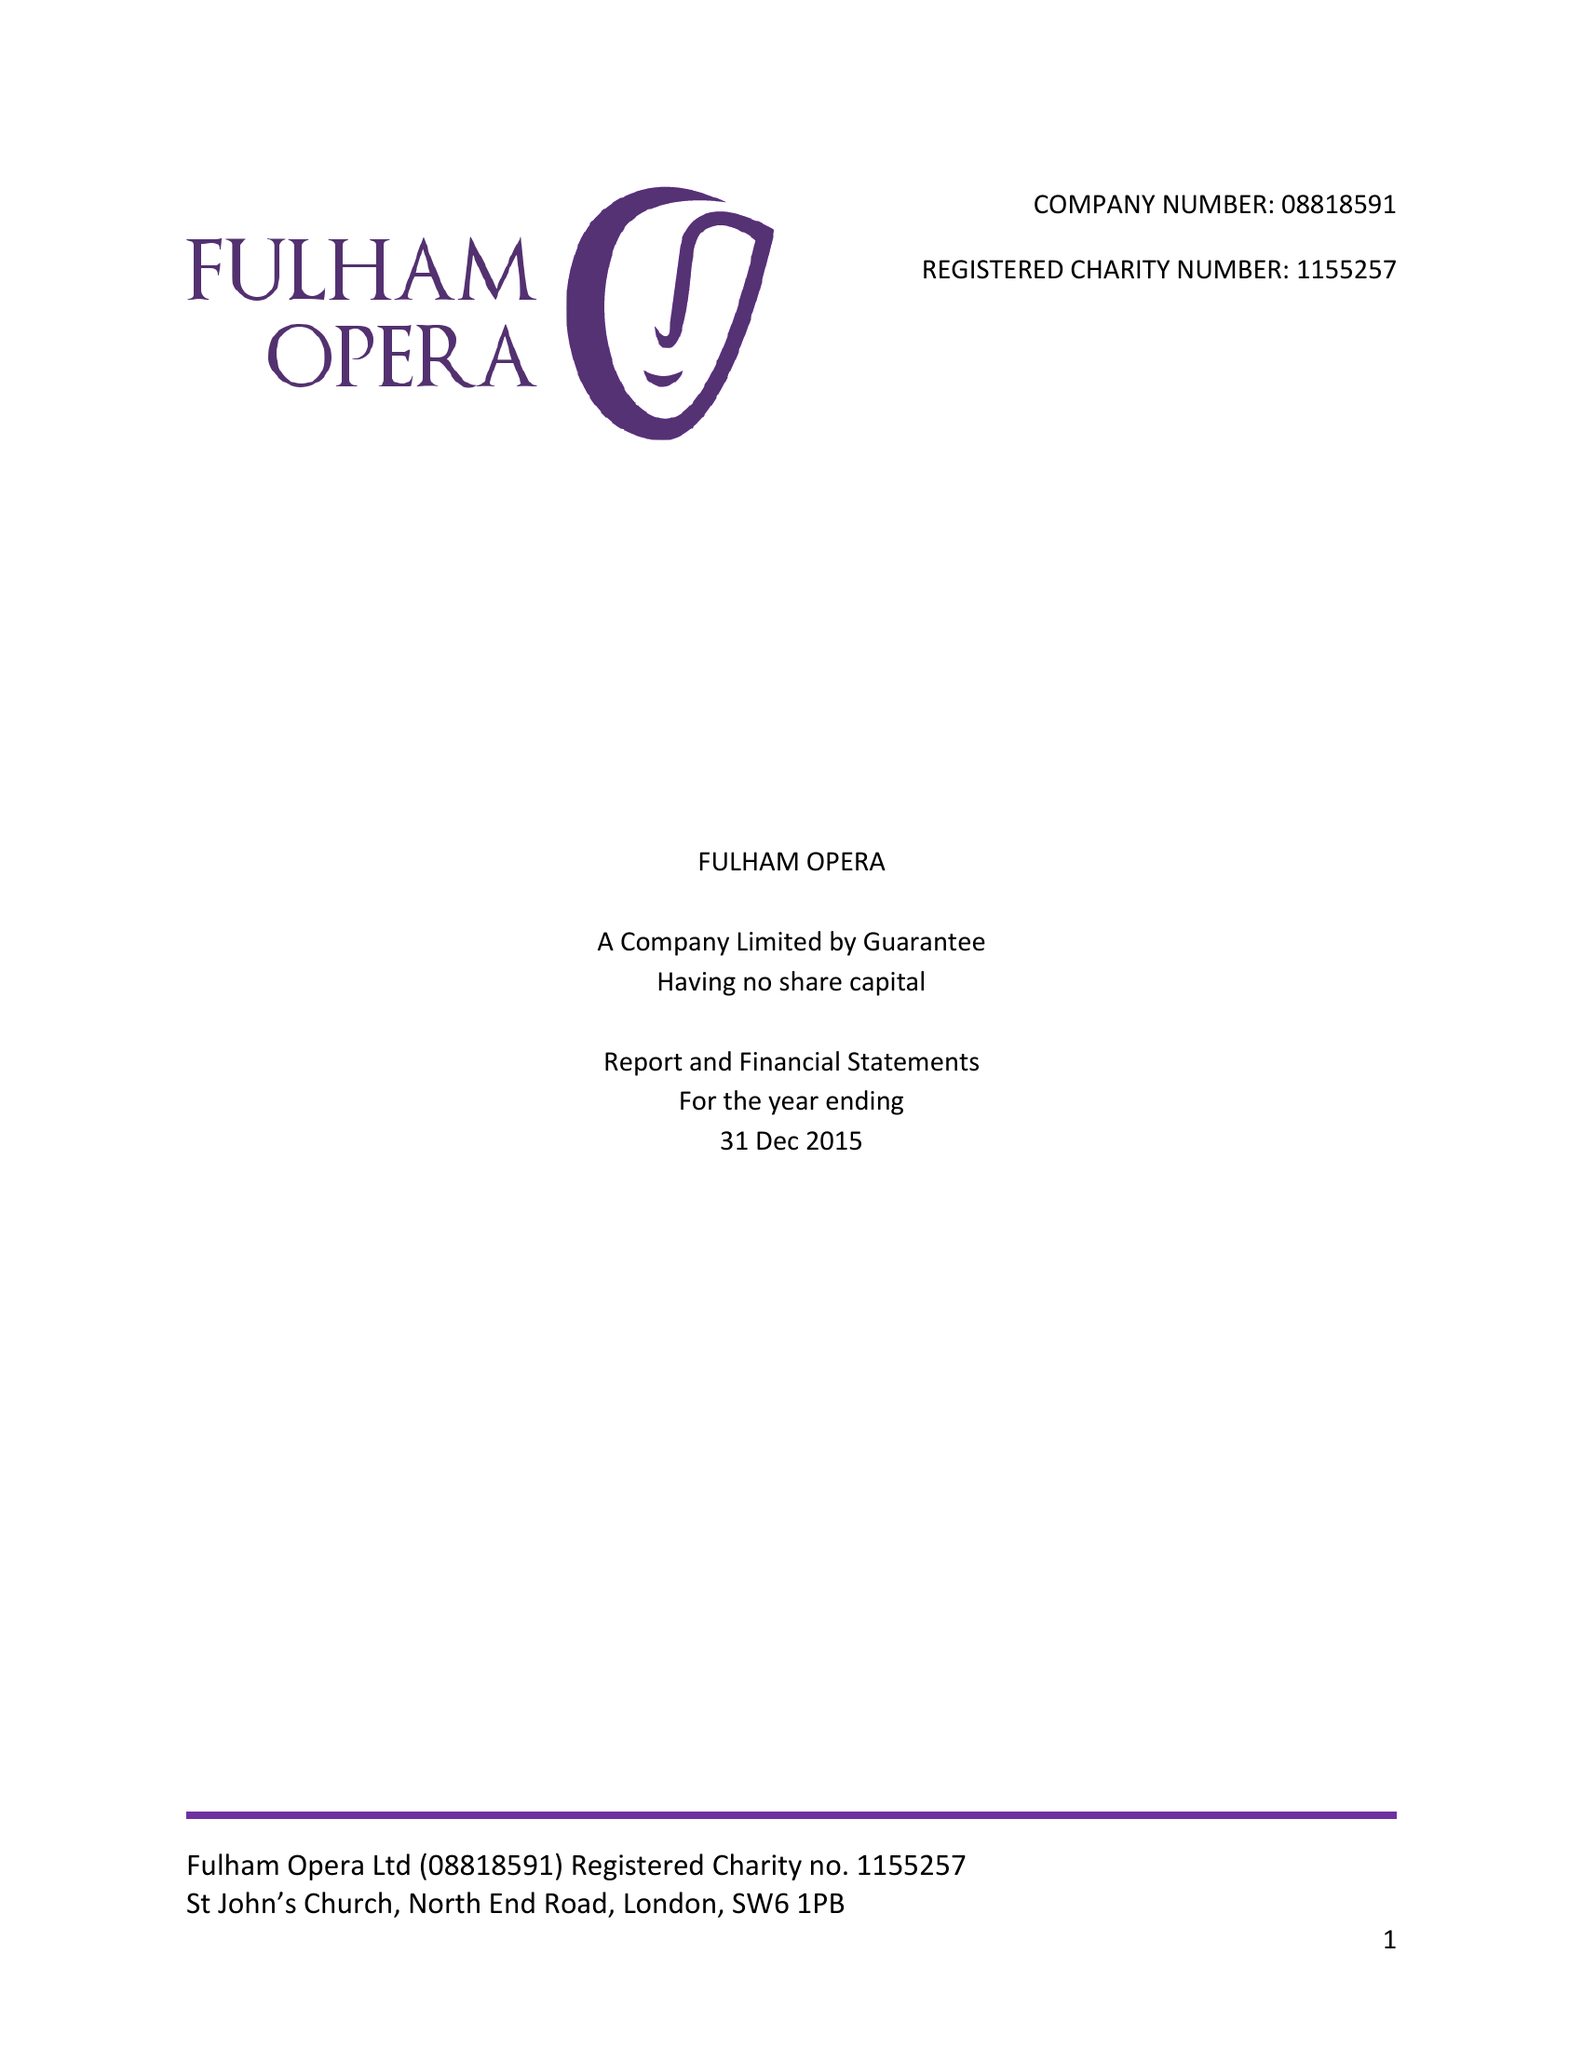What is the value for the spending_annually_in_british_pounds?
Answer the question using a single word or phrase. 59446.00 